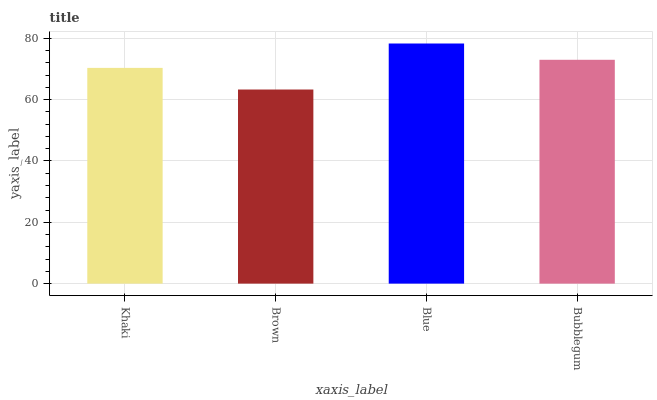Is Blue the minimum?
Answer yes or no. No. Is Brown the maximum?
Answer yes or no. No. Is Blue greater than Brown?
Answer yes or no. Yes. Is Brown less than Blue?
Answer yes or no. Yes. Is Brown greater than Blue?
Answer yes or no. No. Is Blue less than Brown?
Answer yes or no. No. Is Bubblegum the high median?
Answer yes or no. Yes. Is Khaki the low median?
Answer yes or no. Yes. Is Blue the high median?
Answer yes or no. No. Is Blue the low median?
Answer yes or no. No. 